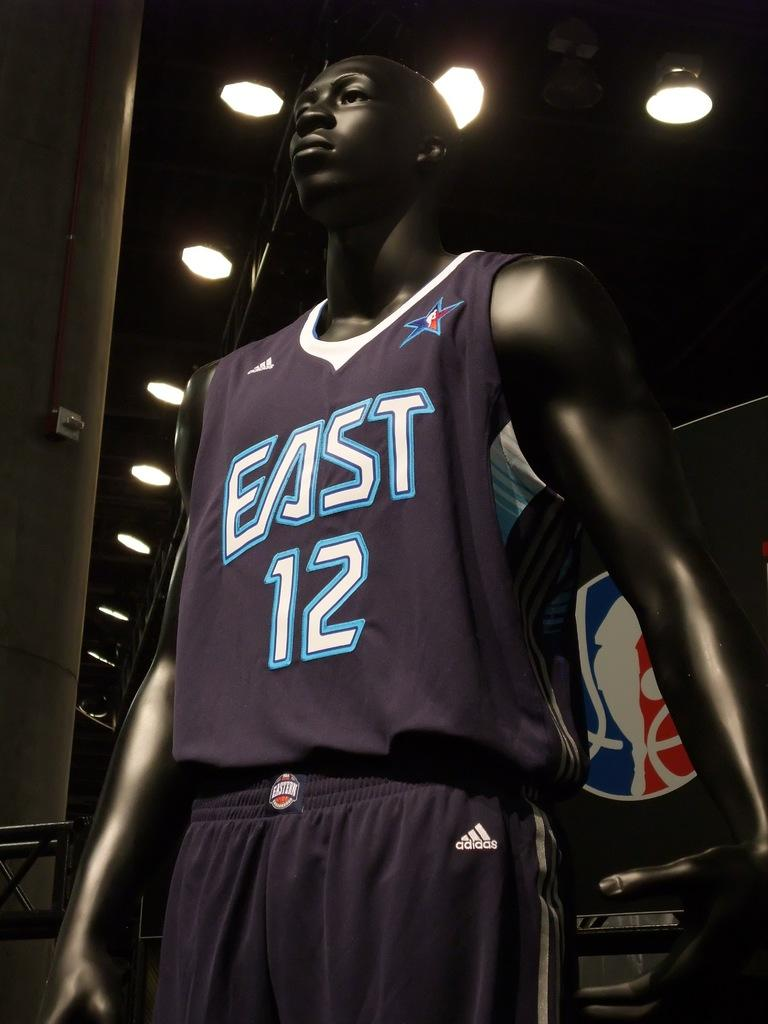<image>
Provide a brief description of the given image. A basketball player mannequin is dressed in an Adidas outfit with East 12 on the front. 